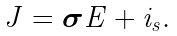<formula> <loc_0><loc_0><loc_500><loc_500>J = \boldsymbol \sigma E + i _ { s } .</formula> 